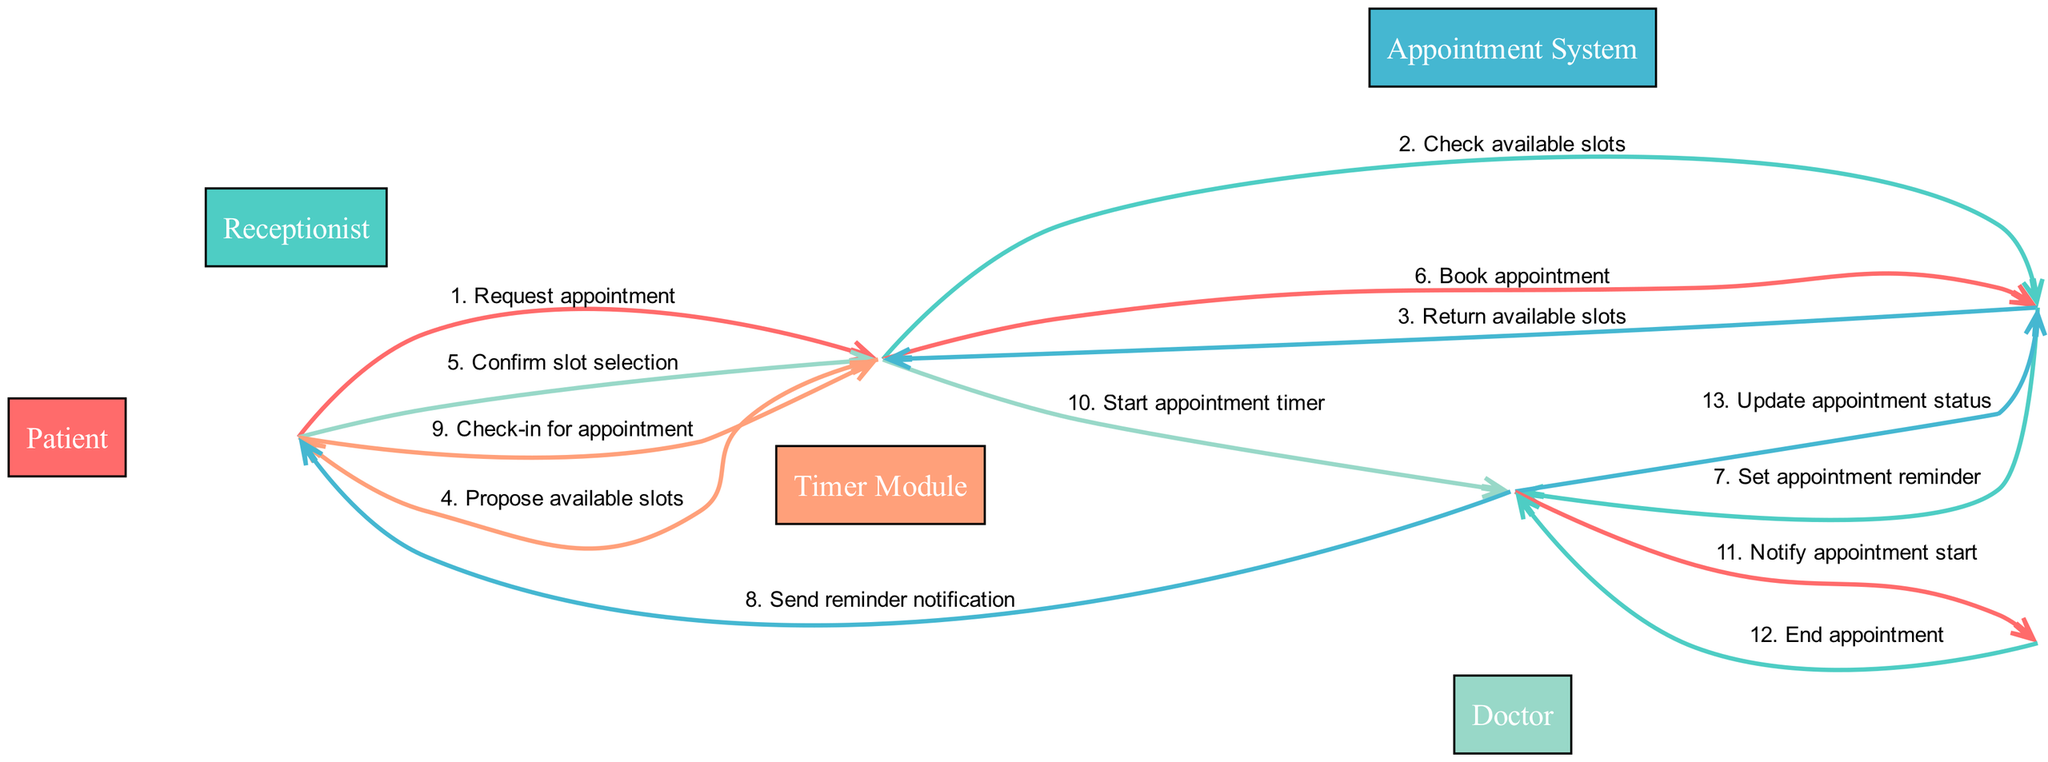What is the first message in the sequence? The first message is sent from the Patient to the Receptionist with the content "Request appointment".
Answer: Request appointment How many actors are involved in the appointment scheduling process? There are five actors involved: Patient, Receptionist, Appointment System, Timer Module, and Doctor.
Answer: Five Who checks the available slots? The Receptionist checks the available slots by sending a message to the Appointment System.
Answer: Receptionist What does the Timer Module send to the Patient? The Timer Module sends a reminder notification to the Patient after setting the appointment reminder.
Answer: Send reminder notification What is the relationship between the Timer Module and the Doctor? The Timer Module notifies the Doctor when the appointment starts.
Answer: Notify appointment start What is the last action taken by the Timer Module? The last action taken is to update the appointment status in the Appointment System after receiving the end appointment signal from the Doctor.
Answer: Update appointment status How many messages are exchanged in total during the scheduling process? There are a total of thirteen messages exchanged throughout the process from the initial request to the final update.
Answer: Thirteen What action follows immediately after the Patient confirms slot selection? The Receptionist books the appointment by sending a message to the Appointment System.
Answer: Book appointment Which actor is responsible for starting the appointment timer? The Receptionist is responsible for starting the appointment timer by sending a message to the Timer Module.
Answer: Receptionist 